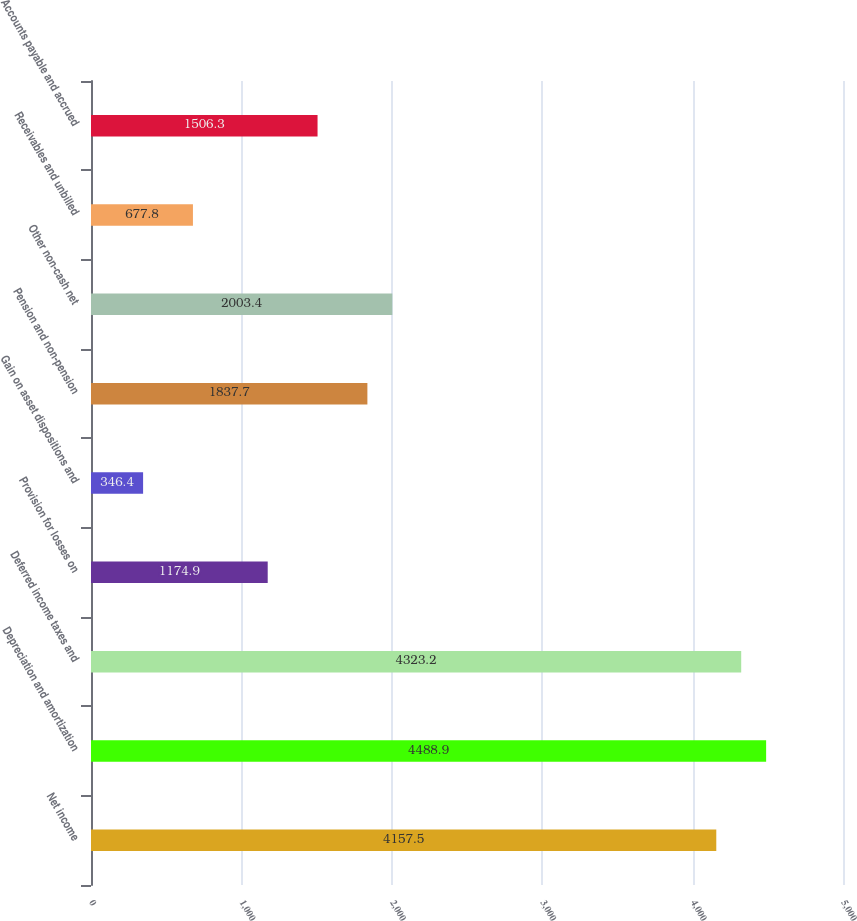Convert chart to OTSL. <chart><loc_0><loc_0><loc_500><loc_500><bar_chart><fcel>Net income<fcel>Depreciation and amortization<fcel>Deferred income taxes and<fcel>Provision for losses on<fcel>Gain on asset dispositions and<fcel>Pension and non-pension<fcel>Other non-cash net<fcel>Receivables and unbilled<fcel>Accounts payable and accrued<nl><fcel>4157.5<fcel>4488.9<fcel>4323.2<fcel>1174.9<fcel>346.4<fcel>1837.7<fcel>2003.4<fcel>677.8<fcel>1506.3<nl></chart> 